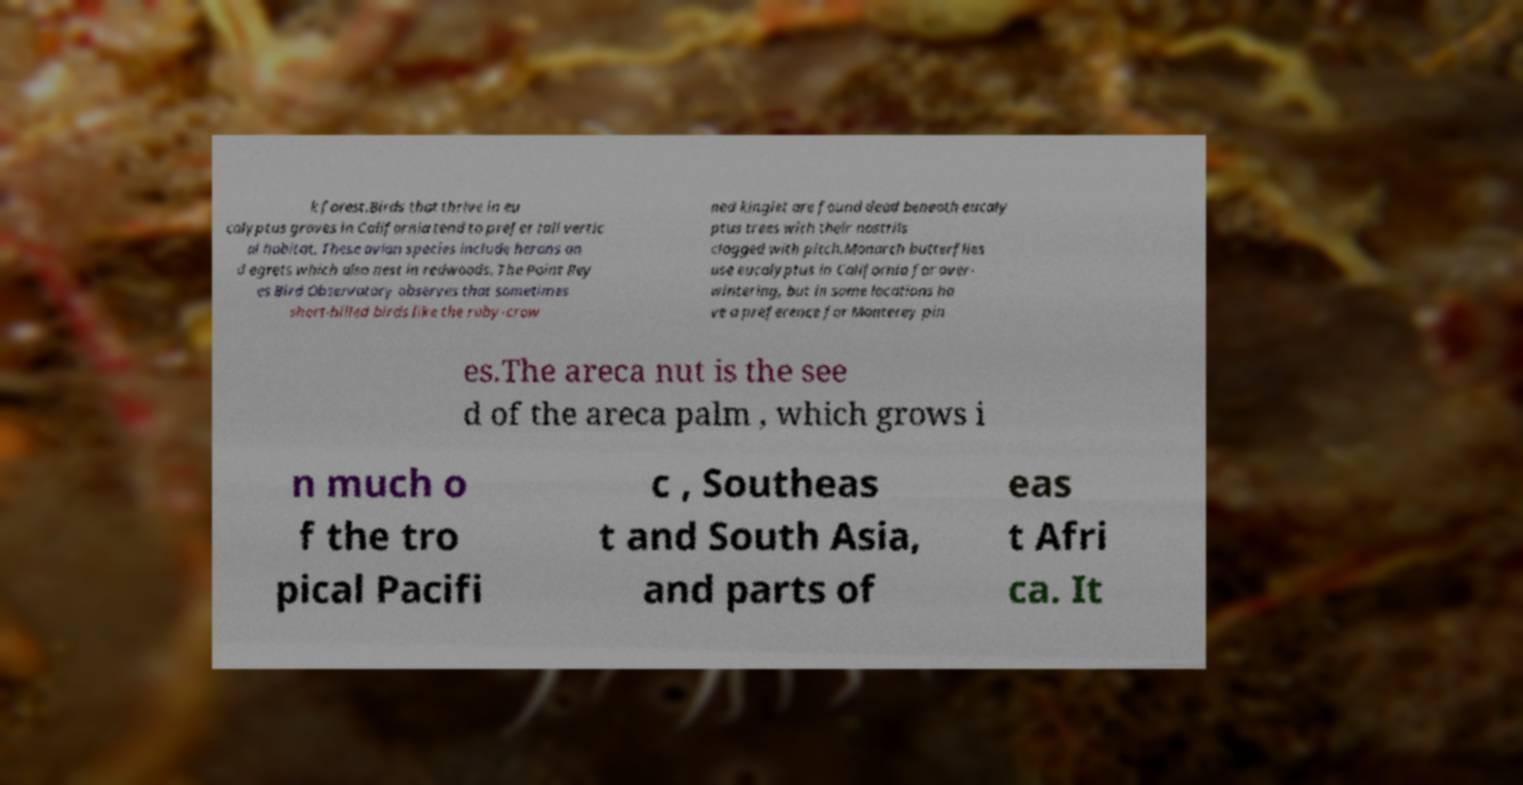Could you assist in decoding the text presented in this image and type it out clearly? k forest.Birds that thrive in eu calyptus groves in California tend to prefer tall vertic al habitat. These avian species include herons an d egrets which also nest in redwoods. The Point Rey es Bird Observatory observes that sometimes short-billed birds like the ruby-crow ned kinglet are found dead beneath eucaly ptus trees with their nostrils clogged with pitch.Monarch butterflies use eucalyptus in California for over- wintering, but in some locations ha ve a preference for Monterey pin es.The areca nut is the see d of the areca palm , which grows i n much o f the tro pical Pacifi c , Southeas t and South Asia, and parts of eas t Afri ca. It 